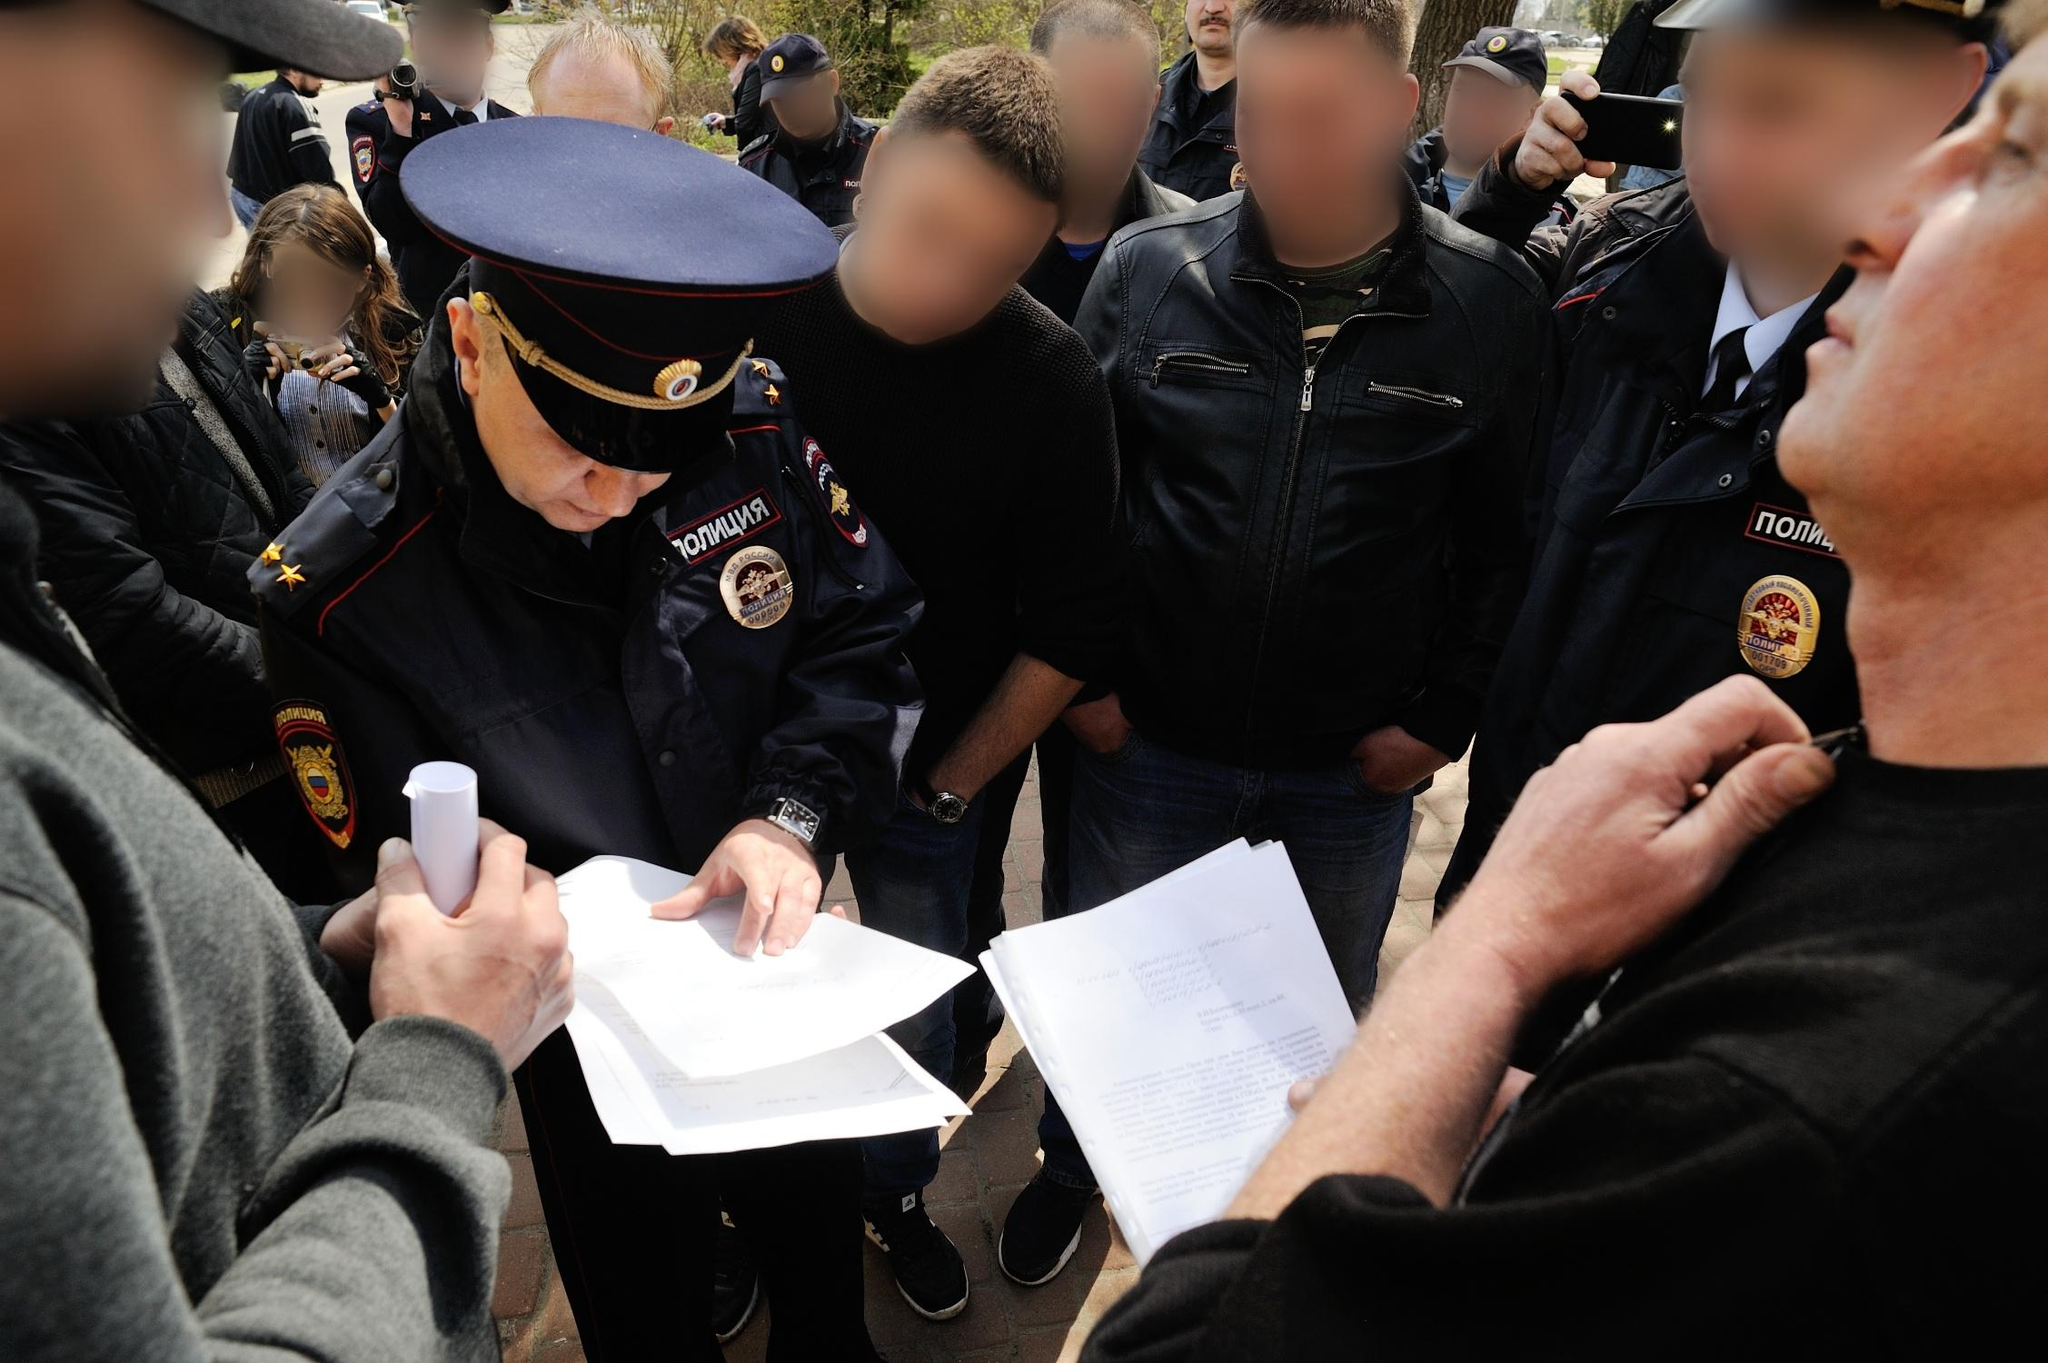What are the people around the officer doing? The individuals surrounding the officer appear to be focused on what he is doing. Some are holding papers, likely related to what the officer is writing down. The general posture of the surrounding people—leaning in, observing closely, or holding documents—suggests they are interested in or directly involved with the actions of the officer. Their blurred faces add an element of anonymity, making the officer the focal point of this public interaction. 